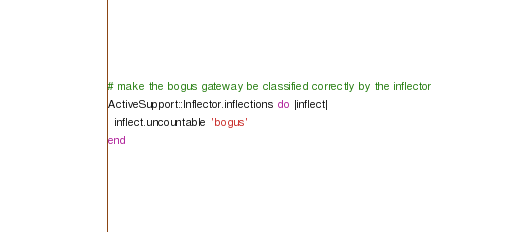Convert code to text. <code><loc_0><loc_0><loc_500><loc_500><_Ruby_># make the bogus gateway be classified correctly by the inflector
ActiveSupport::Inflector.inflections do |inflect|
  inflect.uncountable 'bogus'
end
</code> 